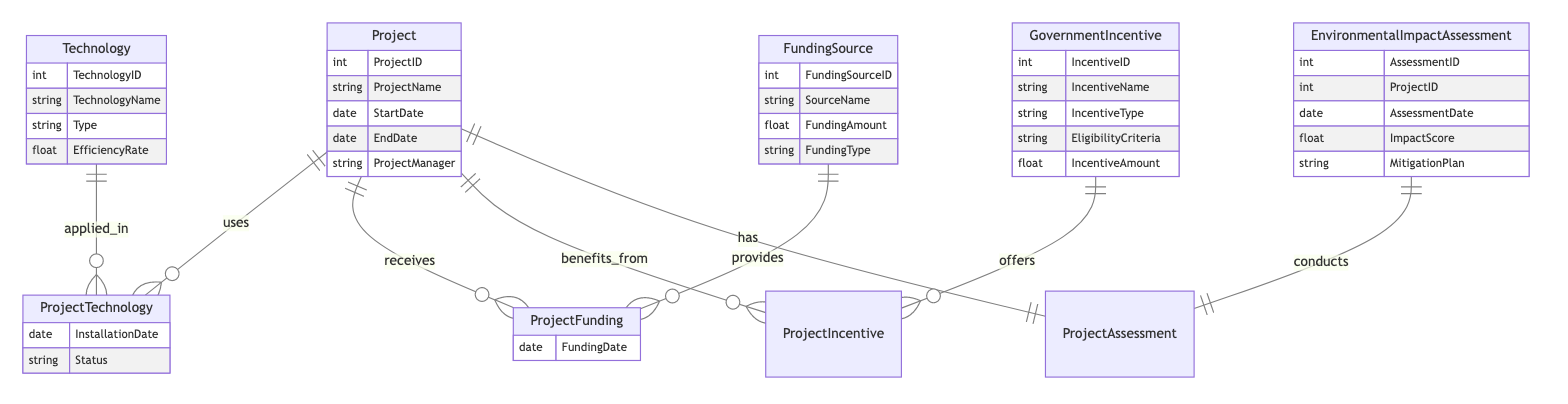What entities are included in the diagram? The diagram contains five entities: Project, Technology, Funding Source, Government Incentive, and Environmental Impact Assessment.
Answer: Project, Technology, Funding Source, Government Incentive, Environmental Impact Assessment How many attributes does the Government Incentive entity have? The Government Incentive entity has five attributes: IncentiveID, IncentiveName, IncentiveType, EligibilityCriteria, and IncentiveAmount.
Answer: Five What is the relationship type between Project and Environmental Impact Assessment? The relationship between Project and Environmental Impact Assessment is one-to-one, indicating that each project has only one corresponding assessment.
Answer: One-to-One What attribute is specific to the ProjectTechnology relationship? The specific attribute of the ProjectTechnology relationship is InstallationDate.
Answer: InstallationDate Which entity provides funding to projects? The Funding Source entity provides funding to projects through the ProjectFunding relationship.
Answer: Funding Source If a project benefits from multiple government incentives, how is that relationship categorized? The relationship is categorized as one-to-many, meaning one project can benefit from multiple incentives.
Answer: One-to-Many What is the total number of relationships depicted in the diagram? There are four relationships illustrated in the diagram: ProjectTechnology, ProjectFunding, ProjectIncentive, and ProjectAssessment.
Answer: Four What is the type of the Technology entity based on its attributes? The Technology entity includes attributes that characterize various technologies, including their Type and Efficiency Rate.
Answer: Type What does the Environmental Impact Assessment's Impact Score represent? The Impact Score represents the evaluated effect of the project on the environment, as assessed on a specific date.
Answer: Impact Score 